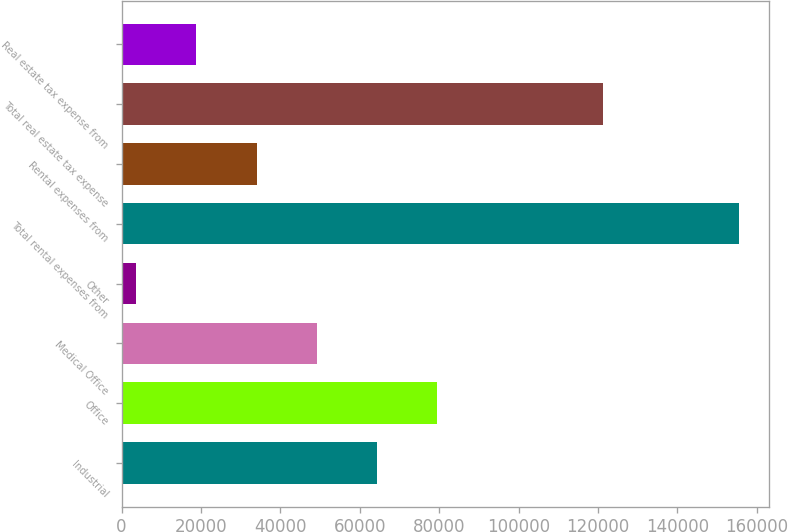<chart> <loc_0><loc_0><loc_500><loc_500><bar_chart><fcel>Industrial<fcel>Office<fcel>Medical Office<fcel>Other<fcel>Total rental expenses from<fcel>Rental expenses from<fcel>Total real estate tax expense<fcel>Real estate tax expense from<nl><fcel>64358.6<fcel>79530.5<fcel>49186.7<fcel>3671<fcel>155390<fcel>34014.8<fcel>121300<fcel>18842.9<nl></chart> 